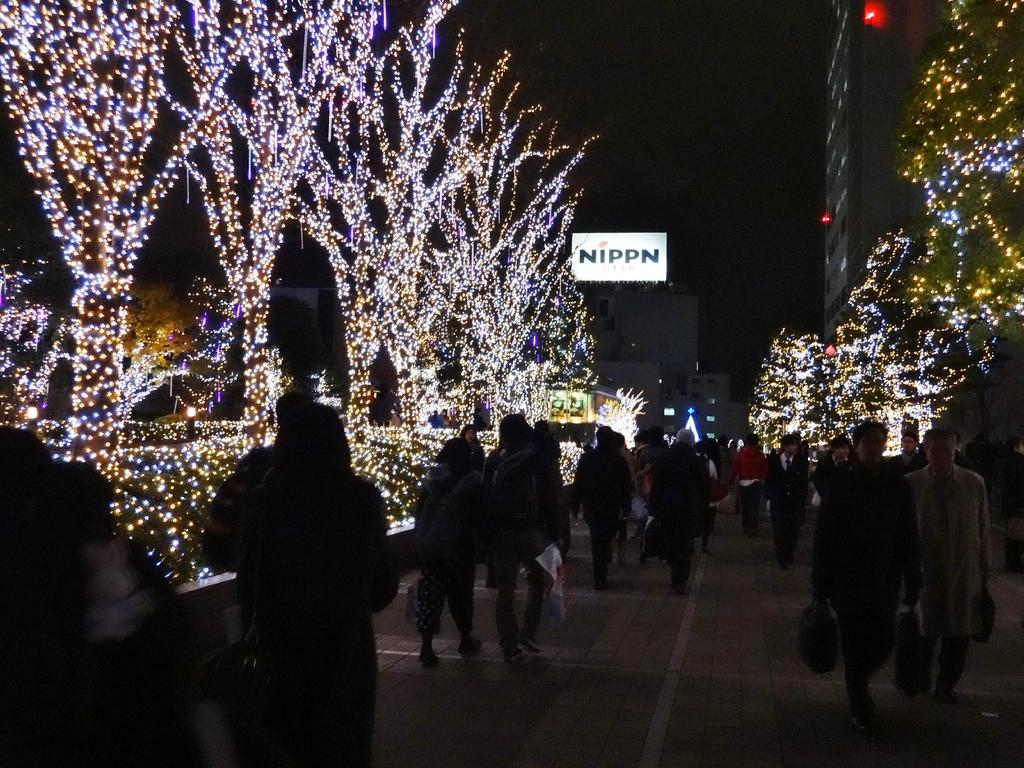What is happening on the road in the image? There are many people walking on the road. What can be seen in the distance behind the people? There are buildings in the background. background. What is the color of the background in the image? The background appears to be black. Can you see a cat sitting on top of a pie in the image? There is no cat or pie present in the image. 